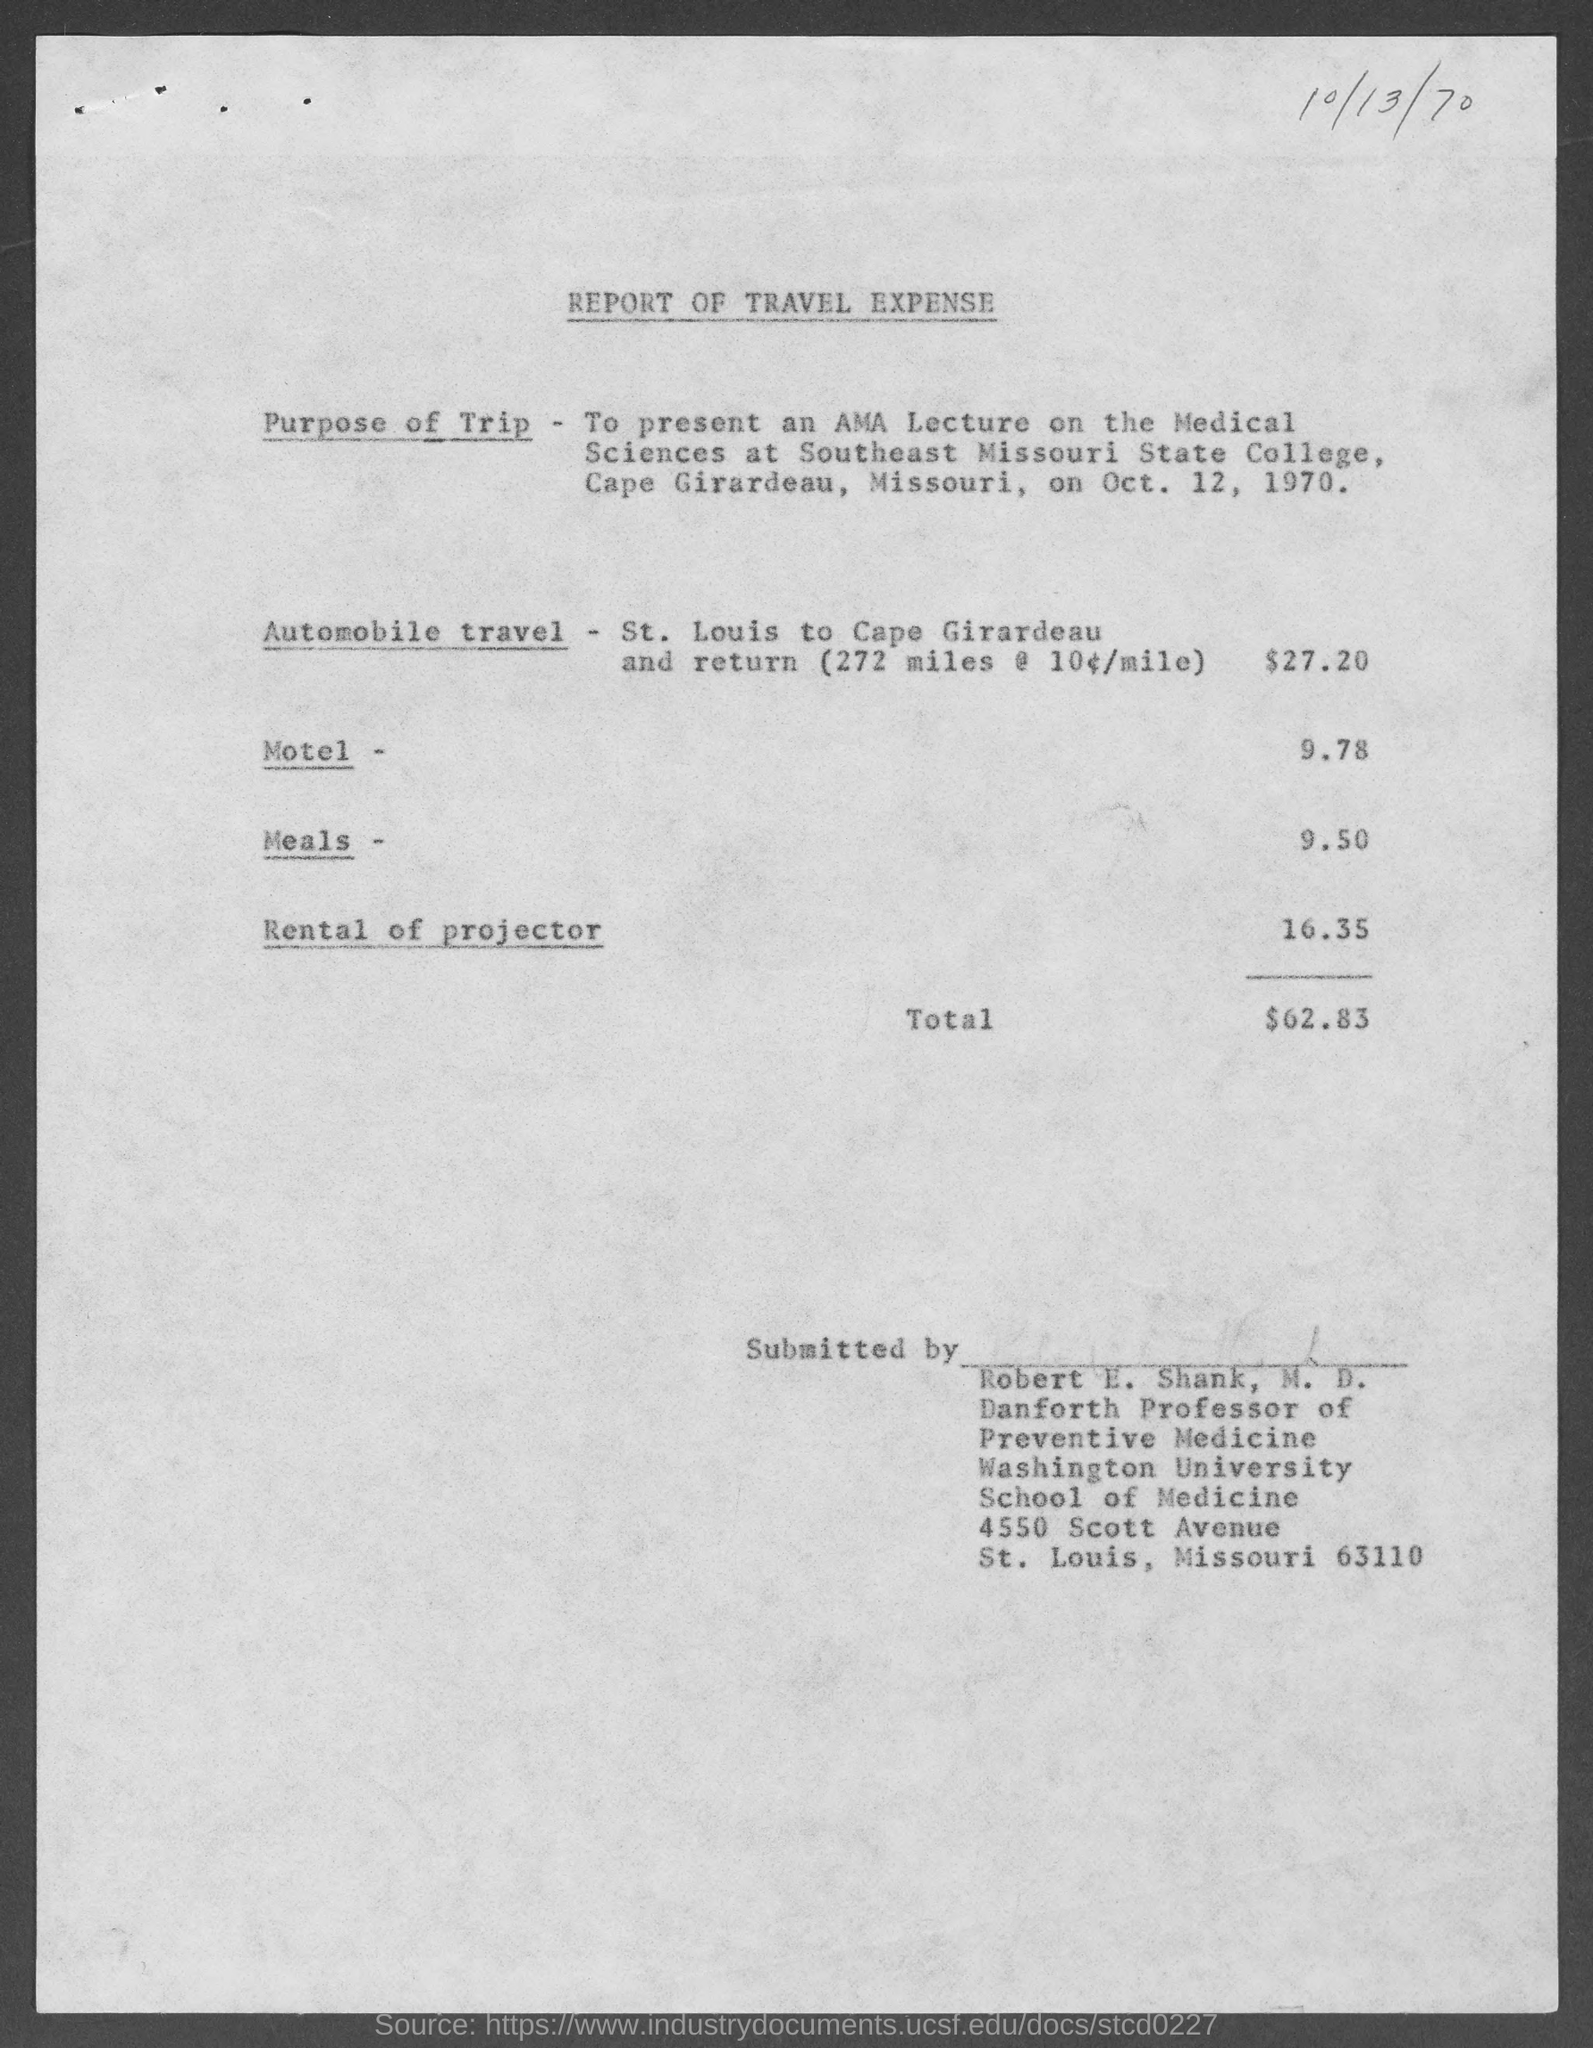What is the street address of washington university school of medicine ?
Your answer should be compact. 4550 Scott Avenue. What is the amount of expense on automobile travel ?
Keep it short and to the point. $27.20. What is the amount of expense on motel ?
Make the answer very short. 9.78. What is the amount of expense on meals ?
Give a very brief answer. $9.50. What is the amount of expense on rental of projector ?
Give a very brief answer. 16.35. What is the total amount of expense ?
Make the answer very short. $62.83. 